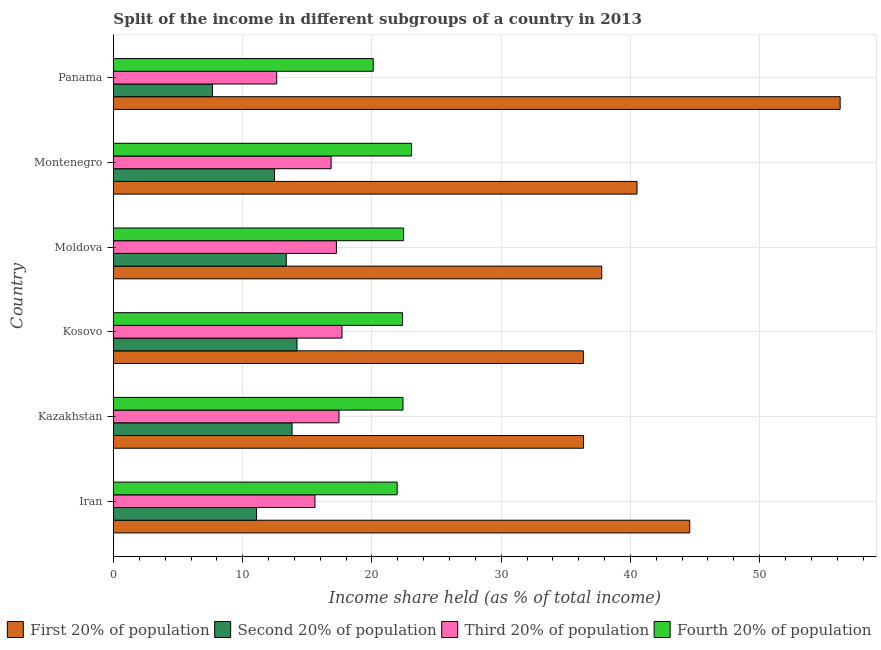How many different coloured bars are there?
Give a very brief answer. 4. Are the number of bars per tick equal to the number of legend labels?
Keep it short and to the point. Yes. How many bars are there on the 3rd tick from the top?
Offer a very short reply. 4. What is the label of the 1st group of bars from the top?
Provide a succinct answer. Panama. In how many cases, is the number of bars for a given country not equal to the number of legend labels?
Your answer should be compact. 0. What is the share of the income held by third 20% of the population in Kosovo?
Your answer should be very brief. 17.68. Across all countries, what is the maximum share of the income held by second 20% of the population?
Your response must be concise. 14.2. Across all countries, what is the minimum share of the income held by first 20% of the population?
Provide a succinct answer. 36.36. In which country was the share of the income held by second 20% of the population maximum?
Provide a succinct answer. Kosovo. In which country was the share of the income held by fourth 20% of the population minimum?
Give a very brief answer. Panama. What is the total share of the income held by fourth 20% of the population in the graph?
Provide a succinct answer. 132.33. What is the difference between the share of the income held by third 20% of the population in Moldova and that in Montenegro?
Ensure brevity in your answer.  0.41. What is the difference between the share of the income held by third 20% of the population in Kosovo and the share of the income held by fourth 20% of the population in Montenegro?
Give a very brief answer. -5.38. What is the average share of the income held by first 20% of the population per country?
Keep it short and to the point. 41.97. What is the difference between the share of the income held by third 20% of the population and share of the income held by second 20% of the population in Kazakhstan?
Provide a short and direct response. 3.63. What is the ratio of the share of the income held by third 20% of the population in Iran to that in Panama?
Offer a very short reply. 1.23. Is the share of the income held by first 20% of the population in Kosovo less than that in Panama?
Your response must be concise. Yes. What is the difference between the highest and the second highest share of the income held by first 20% of the population?
Provide a succinct answer. 11.64. What is the difference between the highest and the lowest share of the income held by third 20% of the population?
Keep it short and to the point. 5.05. Is the sum of the share of the income held by second 20% of the population in Montenegro and Panama greater than the maximum share of the income held by fourth 20% of the population across all countries?
Offer a terse response. No. Is it the case that in every country, the sum of the share of the income held by third 20% of the population and share of the income held by first 20% of the population is greater than the sum of share of the income held by fourth 20% of the population and share of the income held by second 20% of the population?
Offer a terse response. Yes. What does the 2nd bar from the top in Kazakhstan represents?
Offer a very short reply. Third 20% of population. What does the 1st bar from the bottom in Kosovo represents?
Make the answer very short. First 20% of population. Is it the case that in every country, the sum of the share of the income held by first 20% of the population and share of the income held by second 20% of the population is greater than the share of the income held by third 20% of the population?
Ensure brevity in your answer.  Yes. How many bars are there?
Your response must be concise. 24. How many countries are there in the graph?
Your answer should be very brief. 6. Does the graph contain any zero values?
Your answer should be compact. No. Does the graph contain grids?
Offer a terse response. Yes. Where does the legend appear in the graph?
Your answer should be compact. Bottom right. How are the legend labels stacked?
Offer a terse response. Horizontal. What is the title of the graph?
Your answer should be compact. Split of the income in different subgroups of a country in 2013. What is the label or title of the X-axis?
Make the answer very short. Income share held (as % of total income). What is the Income share held (as % of total income) in First 20% of population in Iran?
Offer a terse response. 44.59. What is the Income share held (as % of total income) in Second 20% of population in Iran?
Provide a succinct answer. 11.07. What is the Income share held (as % of total income) in Third 20% of population in Iran?
Make the answer very short. 15.59. What is the Income share held (as % of total income) of Fourth 20% of population in Iran?
Keep it short and to the point. 21.95. What is the Income share held (as % of total income) of First 20% of population in Kazakhstan?
Your answer should be very brief. 36.37. What is the Income share held (as % of total income) in Second 20% of population in Kazakhstan?
Your response must be concise. 13.82. What is the Income share held (as % of total income) in Third 20% of population in Kazakhstan?
Offer a very short reply. 17.45. What is the Income share held (as % of total income) of Fourth 20% of population in Kazakhstan?
Your answer should be very brief. 22.4. What is the Income share held (as % of total income) of First 20% of population in Kosovo?
Keep it short and to the point. 36.36. What is the Income share held (as % of total income) in Third 20% of population in Kosovo?
Provide a succinct answer. 17.68. What is the Income share held (as % of total income) of Fourth 20% of population in Kosovo?
Make the answer very short. 22.37. What is the Income share held (as % of total income) of First 20% of population in Moldova?
Offer a very short reply. 37.78. What is the Income share held (as % of total income) of Second 20% of population in Moldova?
Provide a succinct answer. 13.37. What is the Income share held (as % of total income) in Third 20% of population in Moldova?
Keep it short and to the point. 17.25. What is the Income share held (as % of total income) in Fourth 20% of population in Moldova?
Offer a terse response. 22.45. What is the Income share held (as % of total income) in First 20% of population in Montenegro?
Your response must be concise. 40.51. What is the Income share held (as % of total income) in Second 20% of population in Montenegro?
Your response must be concise. 12.46. What is the Income share held (as % of total income) in Third 20% of population in Montenegro?
Provide a short and direct response. 16.84. What is the Income share held (as % of total income) of Fourth 20% of population in Montenegro?
Offer a terse response. 23.06. What is the Income share held (as % of total income) of First 20% of population in Panama?
Your response must be concise. 56.23. What is the Income share held (as % of total income) of Second 20% of population in Panama?
Your answer should be very brief. 7.66. What is the Income share held (as % of total income) of Third 20% of population in Panama?
Offer a terse response. 12.63. What is the Income share held (as % of total income) in Fourth 20% of population in Panama?
Provide a short and direct response. 20.1. Across all countries, what is the maximum Income share held (as % of total income) in First 20% of population?
Keep it short and to the point. 56.23. Across all countries, what is the maximum Income share held (as % of total income) of Second 20% of population?
Give a very brief answer. 14.2. Across all countries, what is the maximum Income share held (as % of total income) of Third 20% of population?
Offer a very short reply. 17.68. Across all countries, what is the maximum Income share held (as % of total income) of Fourth 20% of population?
Provide a succinct answer. 23.06. Across all countries, what is the minimum Income share held (as % of total income) in First 20% of population?
Provide a succinct answer. 36.36. Across all countries, what is the minimum Income share held (as % of total income) in Second 20% of population?
Your answer should be compact. 7.66. Across all countries, what is the minimum Income share held (as % of total income) in Third 20% of population?
Provide a short and direct response. 12.63. Across all countries, what is the minimum Income share held (as % of total income) of Fourth 20% of population?
Offer a terse response. 20.1. What is the total Income share held (as % of total income) of First 20% of population in the graph?
Provide a succinct answer. 251.84. What is the total Income share held (as % of total income) of Second 20% of population in the graph?
Offer a very short reply. 72.58. What is the total Income share held (as % of total income) of Third 20% of population in the graph?
Make the answer very short. 97.44. What is the total Income share held (as % of total income) in Fourth 20% of population in the graph?
Ensure brevity in your answer.  132.33. What is the difference between the Income share held (as % of total income) in First 20% of population in Iran and that in Kazakhstan?
Give a very brief answer. 8.22. What is the difference between the Income share held (as % of total income) of Second 20% of population in Iran and that in Kazakhstan?
Provide a short and direct response. -2.75. What is the difference between the Income share held (as % of total income) in Third 20% of population in Iran and that in Kazakhstan?
Offer a terse response. -1.86. What is the difference between the Income share held (as % of total income) in Fourth 20% of population in Iran and that in Kazakhstan?
Your answer should be compact. -0.45. What is the difference between the Income share held (as % of total income) of First 20% of population in Iran and that in Kosovo?
Ensure brevity in your answer.  8.23. What is the difference between the Income share held (as % of total income) of Second 20% of population in Iran and that in Kosovo?
Provide a short and direct response. -3.13. What is the difference between the Income share held (as % of total income) of Third 20% of population in Iran and that in Kosovo?
Provide a succinct answer. -2.09. What is the difference between the Income share held (as % of total income) in Fourth 20% of population in Iran and that in Kosovo?
Provide a short and direct response. -0.42. What is the difference between the Income share held (as % of total income) in First 20% of population in Iran and that in Moldova?
Your answer should be very brief. 6.81. What is the difference between the Income share held (as % of total income) of Second 20% of population in Iran and that in Moldova?
Provide a succinct answer. -2.3. What is the difference between the Income share held (as % of total income) in Third 20% of population in Iran and that in Moldova?
Ensure brevity in your answer.  -1.66. What is the difference between the Income share held (as % of total income) of Fourth 20% of population in Iran and that in Moldova?
Your answer should be very brief. -0.5. What is the difference between the Income share held (as % of total income) of First 20% of population in Iran and that in Montenegro?
Provide a short and direct response. 4.08. What is the difference between the Income share held (as % of total income) in Second 20% of population in Iran and that in Montenegro?
Your answer should be compact. -1.39. What is the difference between the Income share held (as % of total income) in Third 20% of population in Iran and that in Montenegro?
Offer a terse response. -1.25. What is the difference between the Income share held (as % of total income) in Fourth 20% of population in Iran and that in Montenegro?
Provide a short and direct response. -1.11. What is the difference between the Income share held (as % of total income) of First 20% of population in Iran and that in Panama?
Give a very brief answer. -11.64. What is the difference between the Income share held (as % of total income) of Second 20% of population in Iran and that in Panama?
Your answer should be very brief. 3.41. What is the difference between the Income share held (as % of total income) in Third 20% of population in Iran and that in Panama?
Give a very brief answer. 2.96. What is the difference between the Income share held (as % of total income) in Fourth 20% of population in Iran and that in Panama?
Make the answer very short. 1.85. What is the difference between the Income share held (as % of total income) of First 20% of population in Kazakhstan and that in Kosovo?
Ensure brevity in your answer.  0.01. What is the difference between the Income share held (as % of total income) in Second 20% of population in Kazakhstan and that in Kosovo?
Keep it short and to the point. -0.38. What is the difference between the Income share held (as % of total income) in Third 20% of population in Kazakhstan and that in Kosovo?
Provide a succinct answer. -0.23. What is the difference between the Income share held (as % of total income) in Fourth 20% of population in Kazakhstan and that in Kosovo?
Provide a short and direct response. 0.03. What is the difference between the Income share held (as % of total income) of First 20% of population in Kazakhstan and that in Moldova?
Provide a succinct answer. -1.41. What is the difference between the Income share held (as % of total income) in Second 20% of population in Kazakhstan and that in Moldova?
Your answer should be very brief. 0.45. What is the difference between the Income share held (as % of total income) of Third 20% of population in Kazakhstan and that in Moldova?
Your response must be concise. 0.2. What is the difference between the Income share held (as % of total income) of First 20% of population in Kazakhstan and that in Montenegro?
Offer a terse response. -4.14. What is the difference between the Income share held (as % of total income) of Second 20% of population in Kazakhstan and that in Montenegro?
Provide a short and direct response. 1.36. What is the difference between the Income share held (as % of total income) in Third 20% of population in Kazakhstan and that in Montenegro?
Offer a very short reply. 0.61. What is the difference between the Income share held (as % of total income) of Fourth 20% of population in Kazakhstan and that in Montenegro?
Your answer should be very brief. -0.66. What is the difference between the Income share held (as % of total income) of First 20% of population in Kazakhstan and that in Panama?
Provide a succinct answer. -19.86. What is the difference between the Income share held (as % of total income) in Second 20% of population in Kazakhstan and that in Panama?
Provide a succinct answer. 6.16. What is the difference between the Income share held (as % of total income) of Third 20% of population in Kazakhstan and that in Panama?
Offer a very short reply. 4.82. What is the difference between the Income share held (as % of total income) in Fourth 20% of population in Kazakhstan and that in Panama?
Make the answer very short. 2.3. What is the difference between the Income share held (as % of total income) in First 20% of population in Kosovo and that in Moldova?
Provide a short and direct response. -1.42. What is the difference between the Income share held (as % of total income) of Second 20% of population in Kosovo and that in Moldova?
Your answer should be very brief. 0.83. What is the difference between the Income share held (as % of total income) of Third 20% of population in Kosovo and that in Moldova?
Your answer should be very brief. 0.43. What is the difference between the Income share held (as % of total income) of Fourth 20% of population in Kosovo and that in Moldova?
Keep it short and to the point. -0.08. What is the difference between the Income share held (as % of total income) of First 20% of population in Kosovo and that in Montenegro?
Provide a succinct answer. -4.15. What is the difference between the Income share held (as % of total income) in Second 20% of population in Kosovo and that in Montenegro?
Give a very brief answer. 1.74. What is the difference between the Income share held (as % of total income) in Third 20% of population in Kosovo and that in Montenegro?
Your response must be concise. 0.84. What is the difference between the Income share held (as % of total income) of Fourth 20% of population in Kosovo and that in Montenegro?
Give a very brief answer. -0.69. What is the difference between the Income share held (as % of total income) in First 20% of population in Kosovo and that in Panama?
Your answer should be very brief. -19.87. What is the difference between the Income share held (as % of total income) in Second 20% of population in Kosovo and that in Panama?
Give a very brief answer. 6.54. What is the difference between the Income share held (as % of total income) in Third 20% of population in Kosovo and that in Panama?
Offer a very short reply. 5.05. What is the difference between the Income share held (as % of total income) of Fourth 20% of population in Kosovo and that in Panama?
Provide a short and direct response. 2.27. What is the difference between the Income share held (as % of total income) of First 20% of population in Moldova and that in Montenegro?
Make the answer very short. -2.73. What is the difference between the Income share held (as % of total income) of Second 20% of population in Moldova and that in Montenegro?
Your response must be concise. 0.91. What is the difference between the Income share held (as % of total income) of Third 20% of population in Moldova and that in Montenegro?
Offer a terse response. 0.41. What is the difference between the Income share held (as % of total income) of Fourth 20% of population in Moldova and that in Montenegro?
Your answer should be very brief. -0.61. What is the difference between the Income share held (as % of total income) of First 20% of population in Moldova and that in Panama?
Make the answer very short. -18.45. What is the difference between the Income share held (as % of total income) in Second 20% of population in Moldova and that in Panama?
Ensure brevity in your answer.  5.71. What is the difference between the Income share held (as % of total income) in Third 20% of population in Moldova and that in Panama?
Make the answer very short. 4.62. What is the difference between the Income share held (as % of total income) in Fourth 20% of population in Moldova and that in Panama?
Offer a terse response. 2.35. What is the difference between the Income share held (as % of total income) of First 20% of population in Montenegro and that in Panama?
Offer a terse response. -15.72. What is the difference between the Income share held (as % of total income) of Third 20% of population in Montenegro and that in Panama?
Offer a very short reply. 4.21. What is the difference between the Income share held (as % of total income) in Fourth 20% of population in Montenegro and that in Panama?
Your response must be concise. 2.96. What is the difference between the Income share held (as % of total income) in First 20% of population in Iran and the Income share held (as % of total income) in Second 20% of population in Kazakhstan?
Ensure brevity in your answer.  30.77. What is the difference between the Income share held (as % of total income) in First 20% of population in Iran and the Income share held (as % of total income) in Third 20% of population in Kazakhstan?
Your answer should be very brief. 27.14. What is the difference between the Income share held (as % of total income) of First 20% of population in Iran and the Income share held (as % of total income) of Fourth 20% of population in Kazakhstan?
Offer a very short reply. 22.19. What is the difference between the Income share held (as % of total income) of Second 20% of population in Iran and the Income share held (as % of total income) of Third 20% of population in Kazakhstan?
Ensure brevity in your answer.  -6.38. What is the difference between the Income share held (as % of total income) of Second 20% of population in Iran and the Income share held (as % of total income) of Fourth 20% of population in Kazakhstan?
Keep it short and to the point. -11.33. What is the difference between the Income share held (as % of total income) in Third 20% of population in Iran and the Income share held (as % of total income) in Fourth 20% of population in Kazakhstan?
Your answer should be compact. -6.81. What is the difference between the Income share held (as % of total income) in First 20% of population in Iran and the Income share held (as % of total income) in Second 20% of population in Kosovo?
Provide a short and direct response. 30.39. What is the difference between the Income share held (as % of total income) in First 20% of population in Iran and the Income share held (as % of total income) in Third 20% of population in Kosovo?
Provide a short and direct response. 26.91. What is the difference between the Income share held (as % of total income) of First 20% of population in Iran and the Income share held (as % of total income) of Fourth 20% of population in Kosovo?
Offer a terse response. 22.22. What is the difference between the Income share held (as % of total income) of Second 20% of population in Iran and the Income share held (as % of total income) of Third 20% of population in Kosovo?
Ensure brevity in your answer.  -6.61. What is the difference between the Income share held (as % of total income) in Second 20% of population in Iran and the Income share held (as % of total income) in Fourth 20% of population in Kosovo?
Provide a succinct answer. -11.3. What is the difference between the Income share held (as % of total income) in Third 20% of population in Iran and the Income share held (as % of total income) in Fourth 20% of population in Kosovo?
Give a very brief answer. -6.78. What is the difference between the Income share held (as % of total income) of First 20% of population in Iran and the Income share held (as % of total income) of Second 20% of population in Moldova?
Provide a short and direct response. 31.22. What is the difference between the Income share held (as % of total income) in First 20% of population in Iran and the Income share held (as % of total income) in Third 20% of population in Moldova?
Provide a succinct answer. 27.34. What is the difference between the Income share held (as % of total income) of First 20% of population in Iran and the Income share held (as % of total income) of Fourth 20% of population in Moldova?
Make the answer very short. 22.14. What is the difference between the Income share held (as % of total income) of Second 20% of population in Iran and the Income share held (as % of total income) of Third 20% of population in Moldova?
Provide a succinct answer. -6.18. What is the difference between the Income share held (as % of total income) of Second 20% of population in Iran and the Income share held (as % of total income) of Fourth 20% of population in Moldova?
Make the answer very short. -11.38. What is the difference between the Income share held (as % of total income) of Third 20% of population in Iran and the Income share held (as % of total income) of Fourth 20% of population in Moldova?
Your answer should be compact. -6.86. What is the difference between the Income share held (as % of total income) of First 20% of population in Iran and the Income share held (as % of total income) of Second 20% of population in Montenegro?
Keep it short and to the point. 32.13. What is the difference between the Income share held (as % of total income) of First 20% of population in Iran and the Income share held (as % of total income) of Third 20% of population in Montenegro?
Your response must be concise. 27.75. What is the difference between the Income share held (as % of total income) in First 20% of population in Iran and the Income share held (as % of total income) in Fourth 20% of population in Montenegro?
Your answer should be very brief. 21.53. What is the difference between the Income share held (as % of total income) in Second 20% of population in Iran and the Income share held (as % of total income) in Third 20% of population in Montenegro?
Your answer should be compact. -5.77. What is the difference between the Income share held (as % of total income) in Second 20% of population in Iran and the Income share held (as % of total income) in Fourth 20% of population in Montenegro?
Provide a succinct answer. -11.99. What is the difference between the Income share held (as % of total income) of Third 20% of population in Iran and the Income share held (as % of total income) of Fourth 20% of population in Montenegro?
Ensure brevity in your answer.  -7.47. What is the difference between the Income share held (as % of total income) of First 20% of population in Iran and the Income share held (as % of total income) of Second 20% of population in Panama?
Give a very brief answer. 36.93. What is the difference between the Income share held (as % of total income) of First 20% of population in Iran and the Income share held (as % of total income) of Third 20% of population in Panama?
Make the answer very short. 31.96. What is the difference between the Income share held (as % of total income) in First 20% of population in Iran and the Income share held (as % of total income) in Fourth 20% of population in Panama?
Your answer should be compact. 24.49. What is the difference between the Income share held (as % of total income) in Second 20% of population in Iran and the Income share held (as % of total income) in Third 20% of population in Panama?
Provide a succinct answer. -1.56. What is the difference between the Income share held (as % of total income) of Second 20% of population in Iran and the Income share held (as % of total income) of Fourth 20% of population in Panama?
Offer a very short reply. -9.03. What is the difference between the Income share held (as % of total income) of Third 20% of population in Iran and the Income share held (as % of total income) of Fourth 20% of population in Panama?
Give a very brief answer. -4.51. What is the difference between the Income share held (as % of total income) in First 20% of population in Kazakhstan and the Income share held (as % of total income) in Second 20% of population in Kosovo?
Your answer should be compact. 22.17. What is the difference between the Income share held (as % of total income) of First 20% of population in Kazakhstan and the Income share held (as % of total income) of Third 20% of population in Kosovo?
Give a very brief answer. 18.69. What is the difference between the Income share held (as % of total income) of Second 20% of population in Kazakhstan and the Income share held (as % of total income) of Third 20% of population in Kosovo?
Your answer should be very brief. -3.86. What is the difference between the Income share held (as % of total income) of Second 20% of population in Kazakhstan and the Income share held (as % of total income) of Fourth 20% of population in Kosovo?
Keep it short and to the point. -8.55. What is the difference between the Income share held (as % of total income) of Third 20% of population in Kazakhstan and the Income share held (as % of total income) of Fourth 20% of population in Kosovo?
Provide a short and direct response. -4.92. What is the difference between the Income share held (as % of total income) in First 20% of population in Kazakhstan and the Income share held (as % of total income) in Third 20% of population in Moldova?
Your answer should be very brief. 19.12. What is the difference between the Income share held (as % of total income) in First 20% of population in Kazakhstan and the Income share held (as % of total income) in Fourth 20% of population in Moldova?
Your answer should be compact. 13.92. What is the difference between the Income share held (as % of total income) in Second 20% of population in Kazakhstan and the Income share held (as % of total income) in Third 20% of population in Moldova?
Give a very brief answer. -3.43. What is the difference between the Income share held (as % of total income) of Second 20% of population in Kazakhstan and the Income share held (as % of total income) of Fourth 20% of population in Moldova?
Offer a very short reply. -8.63. What is the difference between the Income share held (as % of total income) of Third 20% of population in Kazakhstan and the Income share held (as % of total income) of Fourth 20% of population in Moldova?
Give a very brief answer. -5. What is the difference between the Income share held (as % of total income) in First 20% of population in Kazakhstan and the Income share held (as % of total income) in Second 20% of population in Montenegro?
Ensure brevity in your answer.  23.91. What is the difference between the Income share held (as % of total income) of First 20% of population in Kazakhstan and the Income share held (as % of total income) of Third 20% of population in Montenegro?
Ensure brevity in your answer.  19.53. What is the difference between the Income share held (as % of total income) of First 20% of population in Kazakhstan and the Income share held (as % of total income) of Fourth 20% of population in Montenegro?
Keep it short and to the point. 13.31. What is the difference between the Income share held (as % of total income) of Second 20% of population in Kazakhstan and the Income share held (as % of total income) of Third 20% of population in Montenegro?
Provide a short and direct response. -3.02. What is the difference between the Income share held (as % of total income) of Second 20% of population in Kazakhstan and the Income share held (as % of total income) of Fourth 20% of population in Montenegro?
Your answer should be very brief. -9.24. What is the difference between the Income share held (as % of total income) in Third 20% of population in Kazakhstan and the Income share held (as % of total income) in Fourth 20% of population in Montenegro?
Offer a very short reply. -5.61. What is the difference between the Income share held (as % of total income) in First 20% of population in Kazakhstan and the Income share held (as % of total income) in Second 20% of population in Panama?
Make the answer very short. 28.71. What is the difference between the Income share held (as % of total income) in First 20% of population in Kazakhstan and the Income share held (as % of total income) in Third 20% of population in Panama?
Provide a short and direct response. 23.74. What is the difference between the Income share held (as % of total income) of First 20% of population in Kazakhstan and the Income share held (as % of total income) of Fourth 20% of population in Panama?
Your response must be concise. 16.27. What is the difference between the Income share held (as % of total income) of Second 20% of population in Kazakhstan and the Income share held (as % of total income) of Third 20% of population in Panama?
Make the answer very short. 1.19. What is the difference between the Income share held (as % of total income) in Second 20% of population in Kazakhstan and the Income share held (as % of total income) in Fourth 20% of population in Panama?
Your answer should be compact. -6.28. What is the difference between the Income share held (as % of total income) in Third 20% of population in Kazakhstan and the Income share held (as % of total income) in Fourth 20% of population in Panama?
Keep it short and to the point. -2.65. What is the difference between the Income share held (as % of total income) in First 20% of population in Kosovo and the Income share held (as % of total income) in Second 20% of population in Moldova?
Provide a short and direct response. 22.99. What is the difference between the Income share held (as % of total income) in First 20% of population in Kosovo and the Income share held (as % of total income) in Third 20% of population in Moldova?
Your response must be concise. 19.11. What is the difference between the Income share held (as % of total income) of First 20% of population in Kosovo and the Income share held (as % of total income) of Fourth 20% of population in Moldova?
Your answer should be compact. 13.91. What is the difference between the Income share held (as % of total income) in Second 20% of population in Kosovo and the Income share held (as % of total income) in Third 20% of population in Moldova?
Give a very brief answer. -3.05. What is the difference between the Income share held (as % of total income) in Second 20% of population in Kosovo and the Income share held (as % of total income) in Fourth 20% of population in Moldova?
Make the answer very short. -8.25. What is the difference between the Income share held (as % of total income) in Third 20% of population in Kosovo and the Income share held (as % of total income) in Fourth 20% of population in Moldova?
Ensure brevity in your answer.  -4.77. What is the difference between the Income share held (as % of total income) in First 20% of population in Kosovo and the Income share held (as % of total income) in Second 20% of population in Montenegro?
Offer a terse response. 23.9. What is the difference between the Income share held (as % of total income) in First 20% of population in Kosovo and the Income share held (as % of total income) in Third 20% of population in Montenegro?
Keep it short and to the point. 19.52. What is the difference between the Income share held (as % of total income) of First 20% of population in Kosovo and the Income share held (as % of total income) of Fourth 20% of population in Montenegro?
Offer a terse response. 13.3. What is the difference between the Income share held (as % of total income) of Second 20% of population in Kosovo and the Income share held (as % of total income) of Third 20% of population in Montenegro?
Ensure brevity in your answer.  -2.64. What is the difference between the Income share held (as % of total income) in Second 20% of population in Kosovo and the Income share held (as % of total income) in Fourth 20% of population in Montenegro?
Offer a terse response. -8.86. What is the difference between the Income share held (as % of total income) in Third 20% of population in Kosovo and the Income share held (as % of total income) in Fourth 20% of population in Montenegro?
Offer a very short reply. -5.38. What is the difference between the Income share held (as % of total income) of First 20% of population in Kosovo and the Income share held (as % of total income) of Second 20% of population in Panama?
Give a very brief answer. 28.7. What is the difference between the Income share held (as % of total income) in First 20% of population in Kosovo and the Income share held (as % of total income) in Third 20% of population in Panama?
Make the answer very short. 23.73. What is the difference between the Income share held (as % of total income) of First 20% of population in Kosovo and the Income share held (as % of total income) of Fourth 20% of population in Panama?
Provide a short and direct response. 16.26. What is the difference between the Income share held (as % of total income) in Second 20% of population in Kosovo and the Income share held (as % of total income) in Third 20% of population in Panama?
Offer a terse response. 1.57. What is the difference between the Income share held (as % of total income) of Second 20% of population in Kosovo and the Income share held (as % of total income) of Fourth 20% of population in Panama?
Offer a terse response. -5.9. What is the difference between the Income share held (as % of total income) in Third 20% of population in Kosovo and the Income share held (as % of total income) in Fourth 20% of population in Panama?
Give a very brief answer. -2.42. What is the difference between the Income share held (as % of total income) in First 20% of population in Moldova and the Income share held (as % of total income) in Second 20% of population in Montenegro?
Ensure brevity in your answer.  25.32. What is the difference between the Income share held (as % of total income) of First 20% of population in Moldova and the Income share held (as % of total income) of Third 20% of population in Montenegro?
Ensure brevity in your answer.  20.94. What is the difference between the Income share held (as % of total income) in First 20% of population in Moldova and the Income share held (as % of total income) in Fourth 20% of population in Montenegro?
Give a very brief answer. 14.72. What is the difference between the Income share held (as % of total income) of Second 20% of population in Moldova and the Income share held (as % of total income) of Third 20% of population in Montenegro?
Offer a terse response. -3.47. What is the difference between the Income share held (as % of total income) in Second 20% of population in Moldova and the Income share held (as % of total income) in Fourth 20% of population in Montenegro?
Ensure brevity in your answer.  -9.69. What is the difference between the Income share held (as % of total income) in Third 20% of population in Moldova and the Income share held (as % of total income) in Fourth 20% of population in Montenegro?
Provide a short and direct response. -5.81. What is the difference between the Income share held (as % of total income) of First 20% of population in Moldova and the Income share held (as % of total income) of Second 20% of population in Panama?
Ensure brevity in your answer.  30.12. What is the difference between the Income share held (as % of total income) of First 20% of population in Moldova and the Income share held (as % of total income) of Third 20% of population in Panama?
Offer a terse response. 25.15. What is the difference between the Income share held (as % of total income) of First 20% of population in Moldova and the Income share held (as % of total income) of Fourth 20% of population in Panama?
Ensure brevity in your answer.  17.68. What is the difference between the Income share held (as % of total income) of Second 20% of population in Moldova and the Income share held (as % of total income) of Third 20% of population in Panama?
Ensure brevity in your answer.  0.74. What is the difference between the Income share held (as % of total income) of Second 20% of population in Moldova and the Income share held (as % of total income) of Fourth 20% of population in Panama?
Your response must be concise. -6.73. What is the difference between the Income share held (as % of total income) in Third 20% of population in Moldova and the Income share held (as % of total income) in Fourth 20% of population in Panama?
Ensure brevity in your answer.  -2.85. What is the difference between the Income share held (as % of total income) of First 20% of population in Montenegro and the Income share held (as % of total income) of Second 20% of population in Panama?
Give a very brief answer. 32.85. What is the difference between the Income share held (as % of total income) of First 20% of population in Montenegro and the Income share held (as % of total income) of Third 20% of population in Panama?
Make the answer very short. 27.88. What is the difference between the Income share held (as % of total income) in First 20% of population in Montenegro and the Income share held (as % of total income) in Fourth 20% of population in Panama?
Make the answer very short. 20.41. What is the difference between the Income share held (as % of total income) of Second 20% of population in Montenegro and the Income share held (as % of total income) of Third 20% of population in Panama?
Ensure brevity in your answer.  -0.17. What is the difference between the Income share held (as % of total income) of Second 20% of population in Montenegro and the Income share held (as % of total income) of Fourth 20% of population in Panama?
Make the answer very short. -7.64. What is the difference between the Income share held (as % of total income) of Third 20% of population in Montenegro and the Income share held (as % of total income) of Fourth 20% of population in Panama?
Provide a short and direct response. -3.26. What is the average Income share held (as % of total income) of First 20% of population per country?
Your answer should be compact. 41.97. What is the average Income share held (as % of total income) in Second 20% of population per country?
Your answer should be compact. 12.1. What is the average Income share held (as % of total income) in Third 20% of population per country?
Ensure brevity in your answer.  16.24. What is the average Income share held (as % of total income) in Fourth 20% of population per country?
Your answer should be compact. 22.05. What is the difference between the Income share held (as % of total income) of First 20% of population and Income share held (as % of total income) of Second 20% of population in Iran?
Make the answer very short. 33.52. What is the difference between the Income share held (as % of total income) of First 20% of population and Income share held (as % of total income) of Fourth 20% of population in Iran?
Ensure brevity in your answer.  22.64. What is the difference between the Income share held (as % of total income) of Second 20% of population and Income share held (as % of total income) of Third 20% of population in Iran?
Your answer should be very brief. -4.52. What is the difference between the Income share held (as % of total income) in Second 20% of population and Income share held (as % of total income) in Fourth 20% of population in Iran?
Your response must be concise. -10.88. What is the difference between the Income share held (as % of total income) in Third 20% of population and Income share held (as % of total income) in Fourth 20% of population in Iran?
Make the answer very short. -6.36. What is the difference between the Income share held (as % of total income) in First 20% of population and Income share held (as % of total income) in Second 20% of population in Kazakhstan?
Ensure brevity in your answer.  22.55. What is the difference between the Income share held (as % of total income) in First 20% of population and Income share held (as % of total income) in Third 20% of population in Kazakhstan?
Offer a terse response. 18.92. What is the difference between the Income share held (as % of total income) of First 20% of population and Income share held (as % of total income) of Fourth 20% of population in Kazakhstan?
Offer a terse response. 13.97. What is the difference between the Income share held (as % of total income) of Second 20% of population and Income share held (as % of total income) of Third 20% of population in Kazakhstan?
Keep it short and to the point. -3.63. What is the difference between the Income share held (as % of total income) in Second 20% of population and Income share held (as % of total income) in Fourth 20% of population in Kazakhstan?
Ensure brevity in your answer.  -8.58. What is the difference between the Income share held (as % of total income) in Third 20% of population and Income share held (as % of total income) in Fourth 20% of population in Kazakhstan?
Give a very brief answer. -4.95. What is the difference between the Income share held (as % of total income) of First 20% of population and Income share held (as % of total income) of Second 20% of population in Kosovo?
Offer a terse response. 22.16. What is the difference between the Income share held (as % of total income) in First 20% of population and Income share held (as % of total income) in Third 20% of population in Kosovo?
Offer a terse response. 18.68. What is the difference between the Income share held (as % of total income) in First 20% of population and Income share held (as % of total income) in Fourth 20% of population in Kosovo?
Provide a succinct answer. 13.99. What is the difference between the Income share held (as % of total income) of Second 20% of population and Income share held (as % of total income) of Third 20% of population in Kosovo?
Your answer should be compact. -3.48. What is the difference between the Income share held (as % of total income) of Second 20% of population and Income share held (as % of total income) of Fourth 20% of population in Kosovo?
Make the answer very short. -8.17. What is the difference between the Income share held (as % of total income) of Third 20% of population and Income share held (as % of total income) of Fourth 20% of population in Kosovo?
Keep it short and to the point. -4.69. What is the difference between the Income share held (as % of total income) of First 20% of population and Income share held (as % of total income) of Second 20% of population in Moldova?
Your response must be concise. 24.41. What is the difference between the Income share held (as % of total income) in First 20% of population and Income share held (as % of total income) in Third 20% of population in Moldova?
Ensure brevity in your answer.  20.53. What is the difference between the Income share held (as % of total income) of First 20% of population and Income share held (as % of total income) of Fourth 20% of population in Moldova?
Ensure brevity in your answer.  15.33. What is the difference between the Income share held (as % of total income) of Second 20% of population and Income share held (as % of total income) of Third 20% of population in Moldova?
Your answer should be very brief. -3.88. What is the difference between the Income share held (as % of total income) of Second 20% of population and Income share held (as % of total income) of Fourth 20% of population in Moldova?
Make the answer very short. -9.08. What is the difference between the Income share held (as % of total income) of First 20% of population and Income share held (as % of total income) of Second 20% of population in Montenegro?
Ensure brevity in your answer.  28.05. What is the difference between the Income share held (as % of total income) in First 20% of population and Income share held (as % of total income) in Third 20% of population in Montenegro?
Keep it short and to the point. 23.67. What is the difference between the Income share held (as % of total income) in First 20% of population and Income share held (as % of total income) in Fourth 20% of population in Montenegro?
Give a very brief answer. 17.45. What is the difference between the Income share held (as % of total income) in Second 20% of population and Income share held (as % of total income) in Third 20% of population in Montenegro?
Give a very brief answer. -4.38. What is the difference between the Income share held (as % of total income) of Second 20% of population and Income share held (as % of total income) of Fourth 20% of population in Montenegro?
Your answer should be very brief. -10.6. What is the difference between the Income share held (as % of total income) of Third 20% of population and Income share held (as % of total income) of Fourth 20% of population in Montenegro?
Offer a terse response. -6.22. What is the difference between the Income share held (as % of total income) of First 20% of population and Income share held (as % of total income) of Second 20% of population in Panama?
Provide a short and direct response. 48.57. What is the difference between the Income share held (as % of total income) in First 20% of population and Income share held (as % of total income) in Third 20% of population in Panama?
Your response must be concise. 43.6. What is the difference between the Income share held (as % of total income) of First 20% of population and Income share held (as % of total income) of Fourth 20% of population in Panama?
Ensure brevity in your answer.  36.13. What is the difference between the Income share held (as % of total income) in Second 20% of population and Income share held (as % of total income) in Third 20% of population in Panama?
Your response must be concise. -4.97. What is the difference between the Income share held (as % of total income) of Second 20% of population and Income share held (as % of total income) of Fourth 20% of population in Panama?
Your response must be concise. -12.44. What is the difference between the Income share held (as % of total income) in Third 20% of population and Income share held (as % of total income) in Fourth 20% of population in Panama?
Provide a short and direct response. -7.47. What is the ratio of the Income share held (as % of total income) in First 20% of population in Iran to that in Kazakhstan?
Keep it short and to the point. 1.23. What is the ratio of the Income share held (as % of total income) in Second 20% of population in Iran to that in Kazakhstan?
Ensure brevity in your answer.  0.8. What is the ratio of the Income share held (as % of total income) in Third 20% of population in Iran to that in Kazakhstan?
Ensure brevity in your answer.  0.89. What is the ratio of the Income share held (as % of total income) in Fourth 20% of population in Iran to that in Kazakhstan?
Ensure brevity in your answer.  0.98. What is the ratio of the Income share held (as % of total income) of First 20% of population in Iran to that in Kosovo?
Provide a short and direct response. 1.23. What is the ratio of the Income share held (as % of total income) in Second 20% of population in Iran to that in Kosovo?
Keep it short and to the point. 0.78. What is the ratio of the Income share held (as % of total income) of Third 20% of population in Iran to that in Kosovo?
Provide a short and direct response. 0.88. What is the ratio of the Income share held (as % of total income) of Fourth 20% of population in Iran to that in Kosovo?
Keep it short and to the point. 0.98. What is the ratio of the Income share held (as % of total income) in First 20% of population in Iran to that in Moldova?
Your answer should be very brief. 1.18. What is the ratio of the Income share held (as % of total income) in Second 20% of population in Iran to that in Moldova?
Keep it short and to the point. 0.83. What is the ratio of the Income share held (as % of total income) of Third 20% of population in Iran to that in Moldova?
Provide a short and direct response. 0.9. What is the ratio of the Income share held (as % of total income) in Fourth 20% of population in Iran to that in Moldova?
Provide a succinct answer. 0.98. What is the ratio of the Income share held (as % of total income) in First 20% of population in Iran to that in Montenegro?
Offer a very short reply. 1.1. What is the ratio of the Income share held (as % of total income) of Second 20% of population in Iran to that in Montenegro?
Offer a very short reply. 0.89. What is the ratio of the Income share held (as % of total income) of Third 20% of population in Iran to that in Montenegro?
Offer a very short reply. 0.93. What is the ratio of the Income share held (as % of total income) in Fourth 20% of population in Iran to that in Montenegro?
Offer a very short reply. 0.95. What is the ratio of the Income share held (as % of total income) in First 20% of population in Iran to that in Panama?
Your answer should be compact. 0.79. What is the ratio of the Income share held (as % of total income) in Second 20% of population in Iran to that in Panama?
Keep it short and to the point. 1.45. What is the ratio of the Income share held (as % of total income) of Third 20% of population in Iran to that in Panama?
Provide a succinct answer. 1.23. What is the ratio of the Income share held (as % of total income) of Fourth 20% of population in Iran to that in Panama?
Make the answer very short. 1.09. What is the ratio of the Income share held (as % of total income) of First 20% of population in Kazakhstan to that in Kosovo?
Give a very brief answer. 1. What is the ratio of the Income share held (as % of total income) in Second 20% of population in Kazakhstan to that in Kosovo?
Provide a succinct answer. 0.97. What is the ratio of the Income share held (as % of total income) of Third 20% of population in Kazakhstan to that in Kosovo?
Your response must be concise. 0.99. What is the ratio of the Income share held (as % of total income) in Fourth 20% of population in Kazakhstan to that in Kosovo?
Offer a terse response. 1. What is the ratio of the Income share held (as % of total income) in First 20% of population in Kazakhstan to that in Moldova?
Your answer should be compact. 0.96. What is the ratio of the Income share held (as % of total income) in Second 20% of population in Kazakhstan to that in Moldova?
Provide a succinct answer. 1.03. What is the ratio of the Income share held (as % of total income) in Third 20% of population in Kazakhstan to that in Moldova?
Offer a terse response. 1.01. What is the ratio of the Income share held (as % of total income) of First 20% of population in Kazakhstan to that in Montenegro?
Your answer should be compact. 0.9. What is the ratio of the Income share held (as % of total income) of Second 20% of population in Kazakhstan to that in Montenegro?
Ensure brevity in your answer.  1.11. What is the ratio of the Income share held (as % of total income) in Third 20% of population in Kazakhstan to that in Montenegro?
Give a very brief answer. 1.04. What is the ratio of the Income share held (as % of total income) of Fourth 20% of population in Kazakhstan to that in Montenegro?
Keep it short and to the point. 0.97. What is the ratio of the Income share held (as % of total income) of First 20% of population in Kazakhstan to that in Panama?
Your answer should be compact. 0.65. What is the ratio of the Income share held (as % of total income) in Second 20% of population in Kazakhstan to that in Panama?
Make the answer very short. 1.8. What is the ratio of the Income share held (as % of total income) of Third 20% of population in Kazakhstan to that in Panama?
Keep it short and to the point. 1.38. What is the ratio of the Income share held (as % of total income) of Fourth 20% of population in Kazakhstan to that in Panama?
Provide a short and direct response. 1.11. What is the ratio of the Income share held (as % of total income) in First 20% of population in Kosovo to that in Moldova?
Offer a very short reply. 0.96. What is the ratio of the Income share held (as % of total income) in Second 20% of population in Kosovo to that in Moldova?
Provide a succinct answer. 1.06. What is the ratio of the Income share held (as % of total income) of Third 20% of population in Kosovo to that in Moldova?
Provide a short and direct response. 1.02. What is the ratio of the Income share held (as % of total income) in First 20% of population in Kosovo to that in Montenegro?
Your response must be concise. 0.9. What is the ratio of the Income share held (as % of total income) in Second 20% of population in Kosovo to that in Montenegro?
Your answer should be compact. 1.14. What is the ratio of the Income share held (as % of total income) in Third 20% of population in Kosovo to that in Montenegro?
Keep it short and to the point. 1.05. What is the ratio of the Income share held (as % of total income) of Fourth 20% of population in Kosovo to that in Montenegro?
Provide a short and direct response. 0.97. What is the ratio of the Income share held (as % of total income) in First 20% of population in Kosovo to that in Panama?
Provide a short and direct response. 0.65. What is the ratio of the Income share held (as % of total income) in Second 20% of population in Kosovo to that in Panama?
Make the answer very short. 1.85. What is the ratio of the Income share held (as % of total income) in Third 20% of population in Kosovo to that in Panama?
Offer a very short reply. 1.4. What is the ratio of the Income share held (as % of total income) of Fourth 20% of population in Kosovo to that in Panama?
Offer a terse response. 1.11. What is the ratio of the Income share held (as % of total income) of First 20% of population in Moldova to that in Montenegro?
Offer a terse response. 0.93. What is the ratio of the Income share held (as % of total income) in Second 20% of population in Moldova to that in Montenegro?
Provide a short and direct response. 1.07. What is the ratio of the Income share held (as % of total income) of Third 20% of population in Moldova to that in Montenegro?
Your answer should be compact. 1.02. What is the ratio of the Income share held (as % of total income) of Fourth 20% of population in Moldova to that in Montenegro?
Provide a succinct answer. 0.97. What is the ratio of the Income share held (as % of total income) in First 20% of population in Moldova to that in Panama?
Provide a short and direct response. 0.67. What is the ratio of the Income share held (as % of total income) of Second 20% of population in Moldova to that in Panama?
Give a very brief answer. 1.75. What is the ratio of the Income share held (as % of total income) of Third 20% of population in Moldova to that in Panama?
Give a very brief answer. 1.37. What is the ratio of the Income share held (as % of total income) of Fourth 20% of population in Moldova to that in Panama?
Your answer should be compact. 1.12. What is the ratio of the Income share held (as % of total income) in First 20% of population in Montenegro to that in Panama?
Make the answer very short. 0.72. What is the ratio of the Income share held (as % of total income) of Second 20% of population in Montenegro to that in Panama?
Provide a short and direct response. 1.63. What is the ratio of the Income share held (as % of total income) of Fourth 20% of population in Montenegro to that in Panama?
Offer a very short reply. 1.15. What is the difference between the highest and the second highest Income share held (as % of total income) of First 20% of population?
Offer a very short reply. 11.64. What is the difference between the highest and the second highest Income share held (as % of total income) of Second 20% of population?
Offer a very short reply. 0.38. What is the difference between the highest and the second highest Income share held (as % of total income) of Third 20% of population?
Ensure brevity in your answer.  0.23. What is the difference between the highest and the second highest Income share held (as % of total income) in Fourth 20% of population?
Keep it short and to the point. 0.61. What is the difference between the highest and the lowest Income share held (as % of total income) of First 20% of population?
Offer a very short reply. 19.87. What is the difference between the highest and the lowest Income share held (as % of total income) of Second 20% of population?
Keep it short and to the point. 6.54. What is the difference between the highest and the lowest Income share held (as % of total income) in Third 20% of population?
Your answer should be very brief. 5.05. What is the difference between the highest and the lowest Income share held (as % of total income) in Fourth 20% of population?
Make the answer very short. 2.96. 